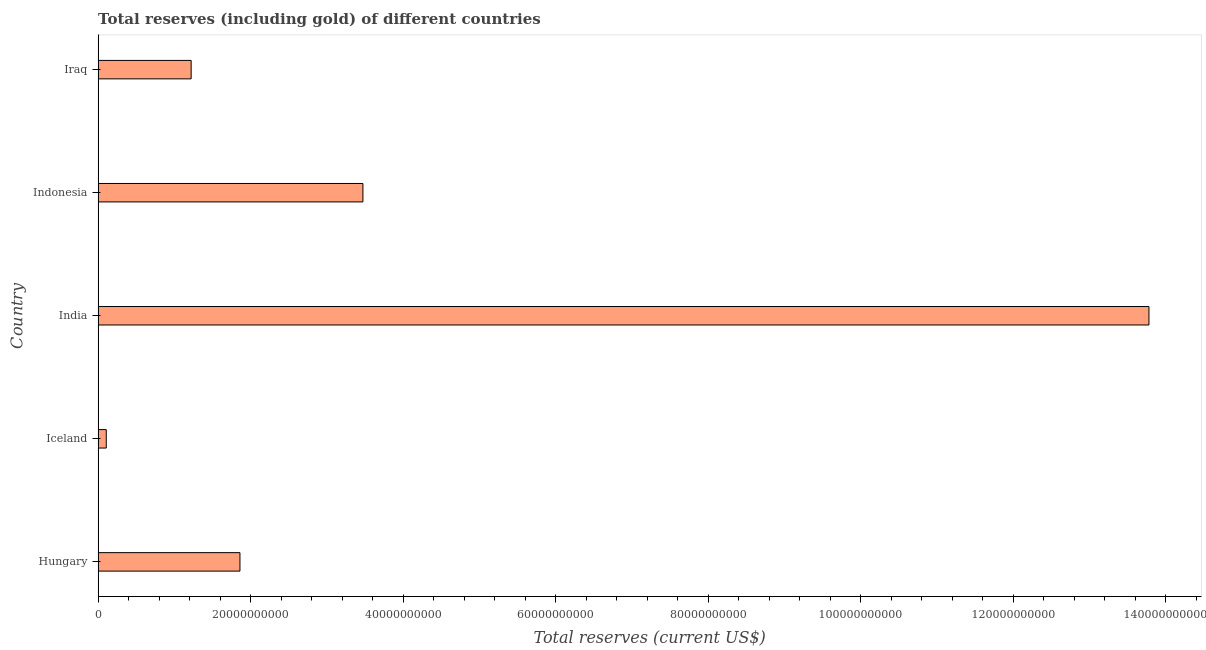What is the title of the graph?
Offer a terse response. Total reserves (including gold) of different countries. What is the label or title of the X-axis?
Offer a terse response. Total reserves (current US$). What is the label or title of the Y-axis?
Offer a terse response. Country. What is the total reserves (including gold) in Indonesia?
Your answer should be compact. 3.47e+1. Across all countries, what is the maximum total reserves (including gold)?
Provide a short and direct response. 1.38e+11. Across all countries, what is the minimum total reserves (including gold)?
Ensure brevity in your answer.  1.07e+09. In which country was the total reserves (including gold) maximum?
Keep it short and to the point. India. What is the sum of the total reserves (including gold)?
Offer a terse response. 2.04e+11. What is the difference between the total reserves (including gold) in Iceland and Indonesia?
Make the answer very short. -3.37e+1. What is the average total reserves (including gold) per country?
Your answer should be very brief. 4.09e+1. What is the median total reserves (including gold)?
Offer a terse response. 1.86e+1. What is the ratio of the total reserves (including gold) in Iceland to that in Indonesia?
Your response must be concise. 0.03. Is the total reserves (including gold) in Iceland less than that in Iraq?
Your answer should be compact. Yes. Is the difference between the total reserves (including gold) in India and Indonesia greater than the difference between any two countries?
Offer a very short reply. No. What is the difference between the highest and the second highest total reserves (including gold)?
Your response must be concise. 1.03e+11. Is the sum of the total reserves (including gold) in Iceland and India greater than the maximum total reserves (including gold) across all countries?
Give a very brief answer. Yes. What is the difference between the highest and the lowest total reserves (including gold)?
Keep it short and to the point. 1.37e+11. How many bars are there?
Your response must be concise. 5. How many countries are there in the graph?
Keep it short and to the point. 5. What is the difference between two consecutive major ticks on the X-axis?
Provide a short and direct response. 2.00e+1. What is the Total reserves (current US$) in Hungary?
Keep it short and to the point. 1.86e+1. What is the Total reserves (current US$) in Iceland?
Ensure brevity in your answer.  1.07e+09. What is the Total reserves (current US$) of India?
Your answer should be compact. 1.38e+11. What is the Total reserves (current US$) of Indonesia?
Your answer should be compact. 3.47e+1. What is the Total reserves (current US$) in Iraq?
Keep it short and to the point. 1.22e+1. What is the difference between the Total reserves (current US$) in Hungary and Iceland?
Offer a very short reply. 1.75e+1. What is the difference between the Total reserves (current US$) in Hungary and India?
Ensure brevity in your answer.  -1.19e+11. What is the difference between the Total reserves (current US$) in Hungary and Indonesia?
Provide a succinct answer. -1.61e+1. What is the difference between the Total reserves (current US$) in Hungary and Iraq?
Provide a succinct answer. 6.40e+09. What is the difference between the Total reserves (current US$) in Iceland and India?
Give a very brief answer. -1.37e+11. What is the difference between the Total reserves (current US$) in Iceland and Indonesia?
Make the answer very short. -3.37e+1. What is the difference between the Total reserves (current US$) in Iceland and Iraq?
Offer a very short reply. -1.11e+1. What is the difference between the Total reserves (current US$) in India and Indonesia?
Your answer should be very brief. 1.03e+11. What is the difference between the Total reserves (current US$) in India and Iraq?
Your answer should be compact. 1.26e+11. What is the difference between the Total reserves (current US$) in Indonesia and Iraq?
Provide a succinct answer. 2.25e+1. What is the ratio of the Total reserves (current US$) in Hungary to that in Iceland?
Offer a terse response. 17.41. What is the ratio of the Total reserves (current US$) in Hungary to that in India?
Offer a very short reply. 0.14. What is the ratio of the Total reserves (current US$) in Hungary to that in Indonesia?
Your response must be concise. 0.54. What is the ratio of the Total reserves (current US$) in Hungary to that in Iraq?
Your answer should be very brief. 1.52. What is the ratio of the Total reserves (current US$) in Iceland to that in India?
Ensure brevity in your answer.  0.01. What is the ratio of the Total reserves (current US$) in Iceland to that in Indonesia?
Offer a terse response. 0.03. What is the ratio of the Total reserves (current US$) in Iceland to that in Iraq?
Your response must be concise. 0.09. What is the ratio of the Total reserves (current US$) in India to that in Indonesia?
Keep it short and to the point. 3.97. What is the ratio of the Total reserves (current US$) in India to that in Iraq?
Give a very brief answer. 11.3. What is the ratio of the Total reserves (current US$) in Indonesia to that in Iraq?
Your answer should be very brief. 2.85. 